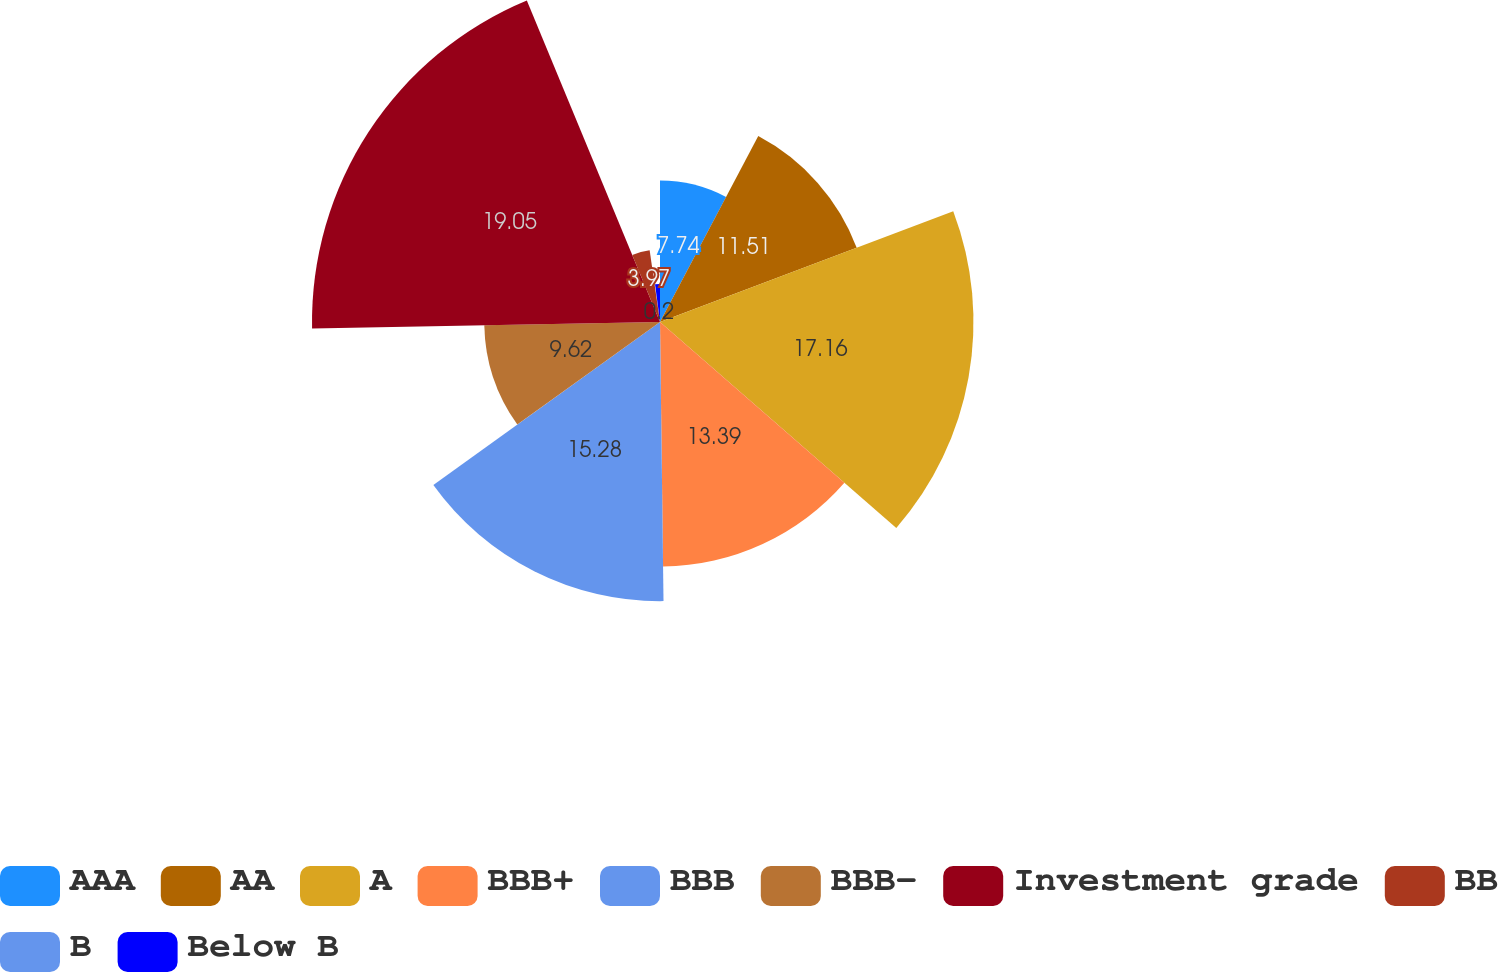Convert chart to OTSL. <chart><loc_0><loc_0><loc_500><loc_500><pie_chart><fcel>AAA<fcel>AA<fcel>A<fcel>BBB+<fcel>BBB<fcel>BBB-<fcel>Investment grade<fcel>BB<fcel>B<fcel>Below B<nl><fcel>7.74%<fcel>11.51%<fcel>17.16%<fcel>13.39%<fcel>15.28%<fcel>9.62%<fcel>19.05%<fcel>3.97%<fcel>0.2%<fcel>2.08%<nl></chart> 